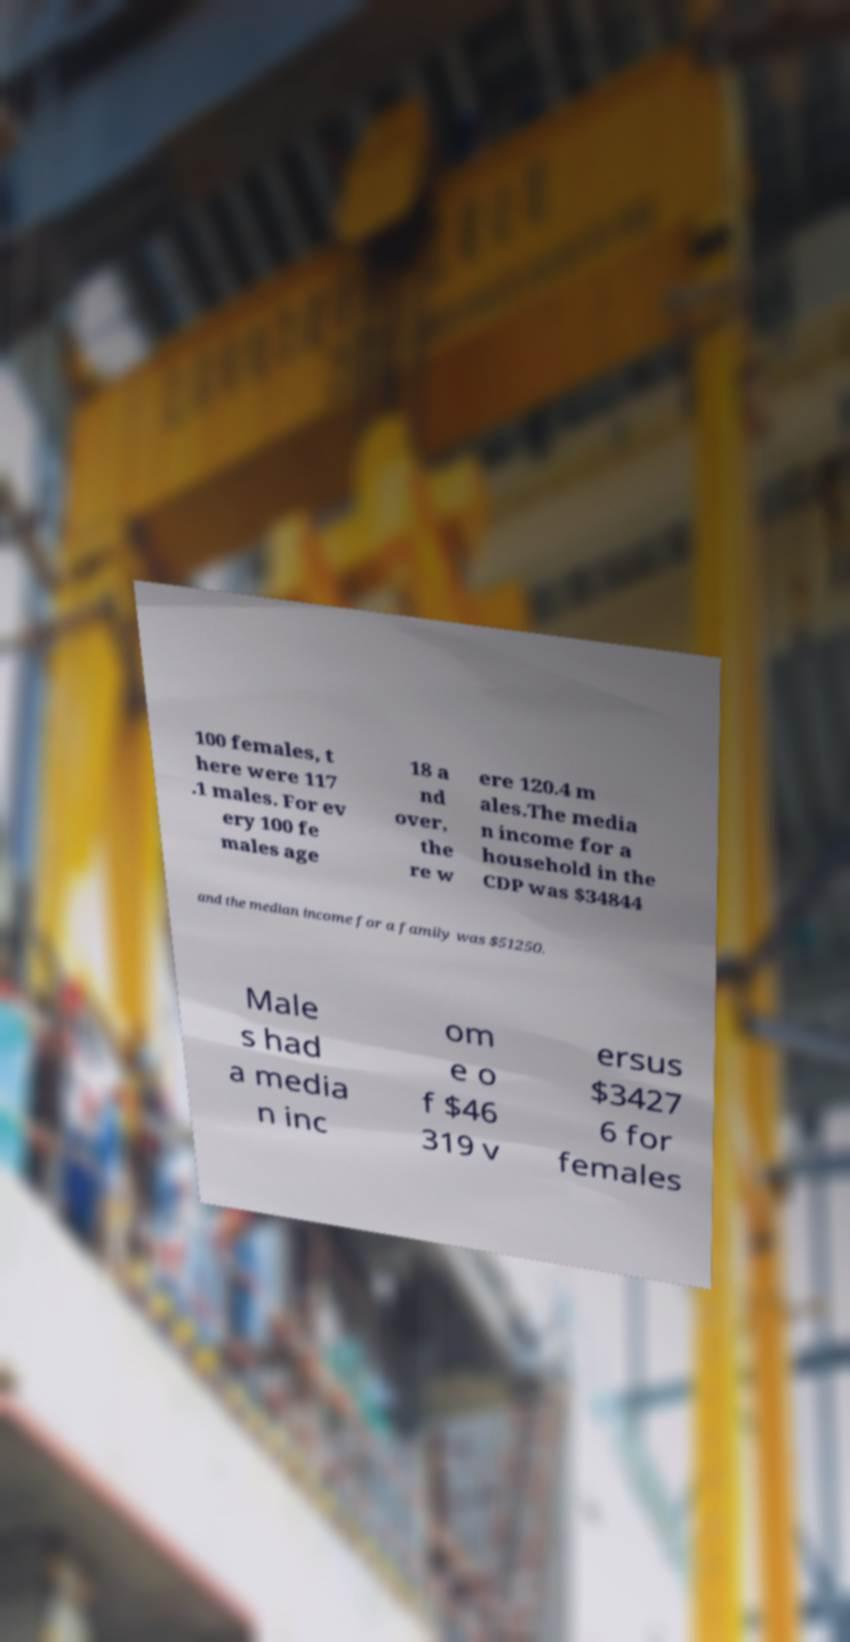There's text embedded in this image that I need extracted. Can you transcribe it verbatim? 100 females, t here were 117 .1 males. For ev ery 100 fe males age 18 a nd over, the re w ere 120.4 m ales.The media n income for a household in the CDP was $34844 and the median income for a family was $51250. Male s had a media n inc om e o f $46 319 v ersus $3427 6 for females 